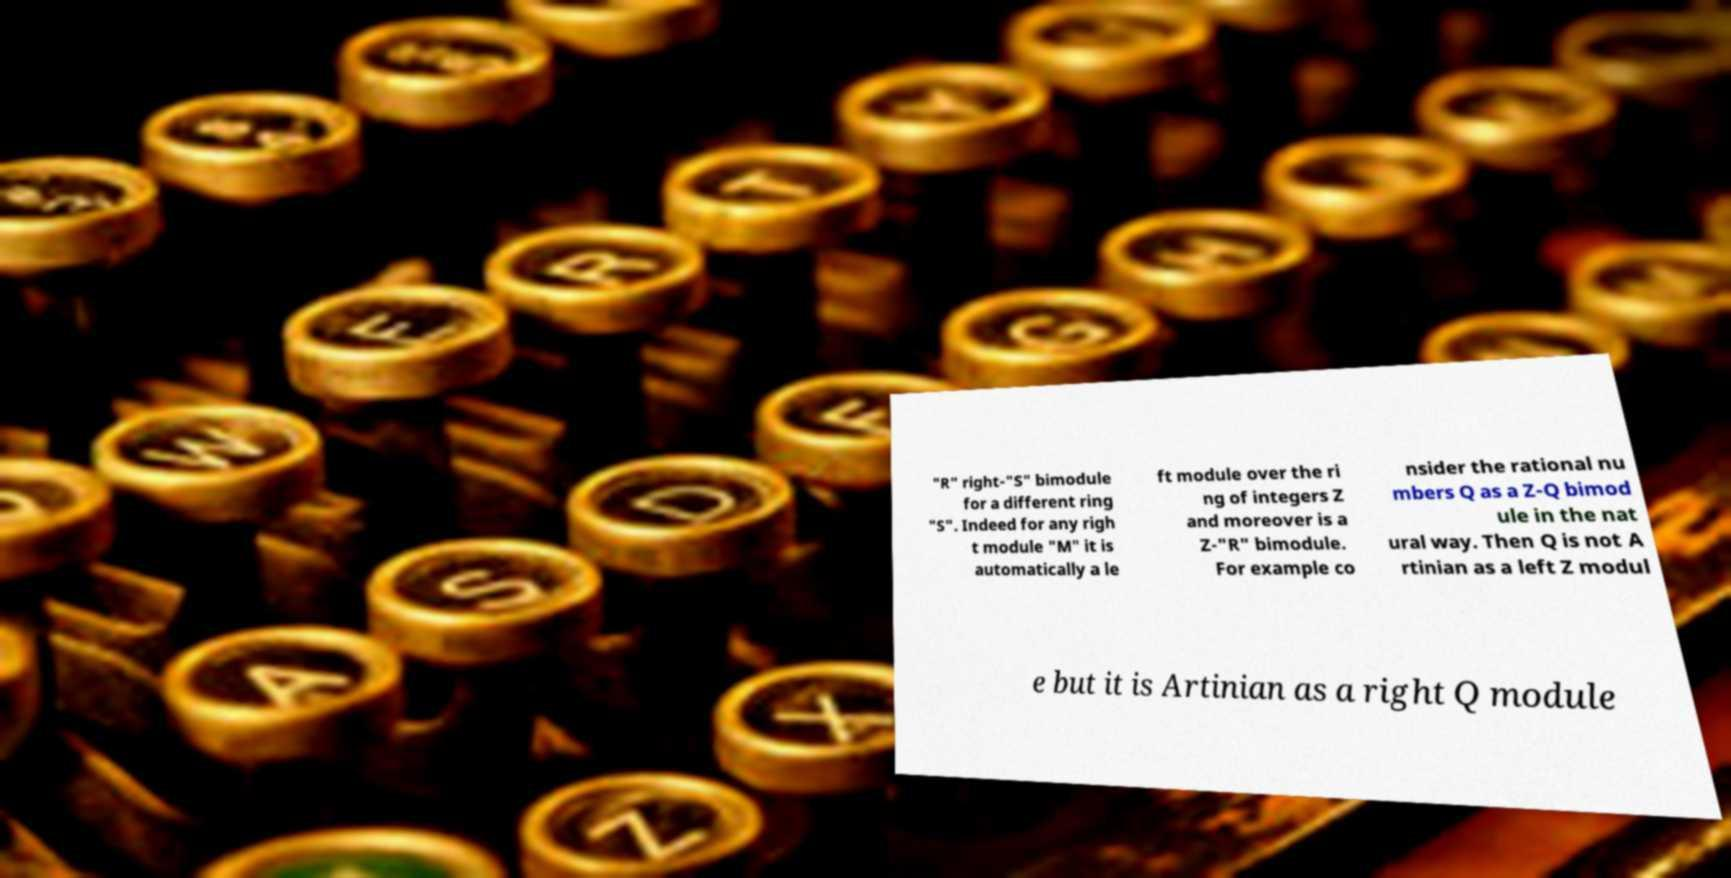Could you assist in decoding the text presented in this image and type it out clearly? "R" right-"S" bimodule for a different ring "S". Indeed for any righ t module "M" it is automatically a le ft module over the ri ng of integers Z and moreover is a Z-"R" bimodule. For example co nsider the rational nu mbers Q as a Z-Q bimod ule in the nat ural way. Then Q is not A rtinian as a left Z modul e but it is Artinian as a right Q module 